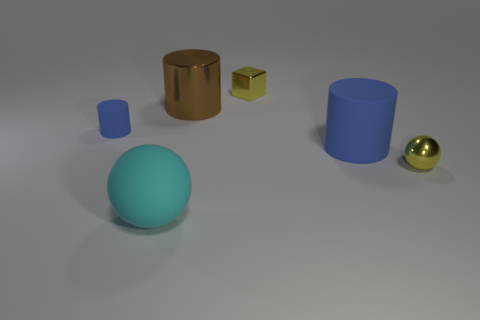The yellow object that is the same size as the shiny ball is what shape?
Provide a succinct answer. Cube. There is a blue thing on the left side of the big brown cylinder; is there a large shiny object that is in front of it?
Your answer should be compact. No. How many large things are either brown cylinders or purple metallic balls?
Give a very brief answer. 1. Is there a cyan ball of the same size as the yellow metallic cube?
Keep it short and to the point. No. How many rubber things are either large brown blocks or cylinders?
Give a very brief answer. 2. What is the shape of the metal thing that is the same color as the metallic ball?
Ensure brevity in your answer.  Cube. How many large cyan rubber balls are there?
Your answer should be very brief. 1. Does the thing that is to the left of the big cyan thing have the same material as the small yellow thing that is behind the small yellow shiny ball?
Your answer should be very brief. No. What size is the blue cylinder that is the same material as the tiny blue object?
Make the answer very short. Large. What shape is the big matte thing that is behind the small shiny sphere?
Offer a very short reply. Cylinder. 